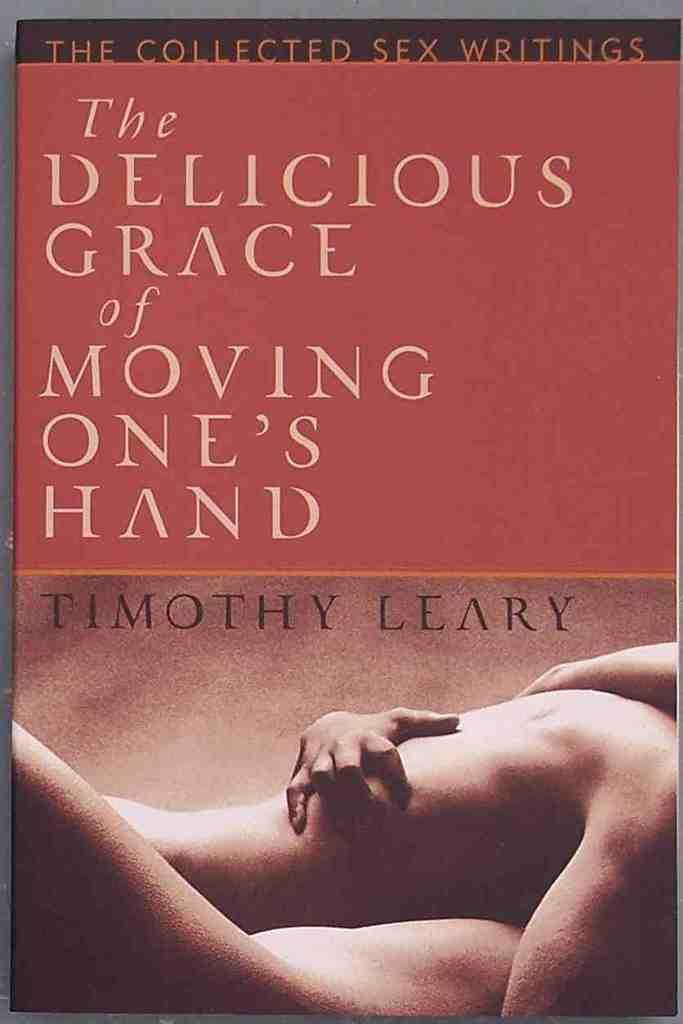<image>
Give a short and clear explanation of the subsequent image. A book about sex lays on a surface. 